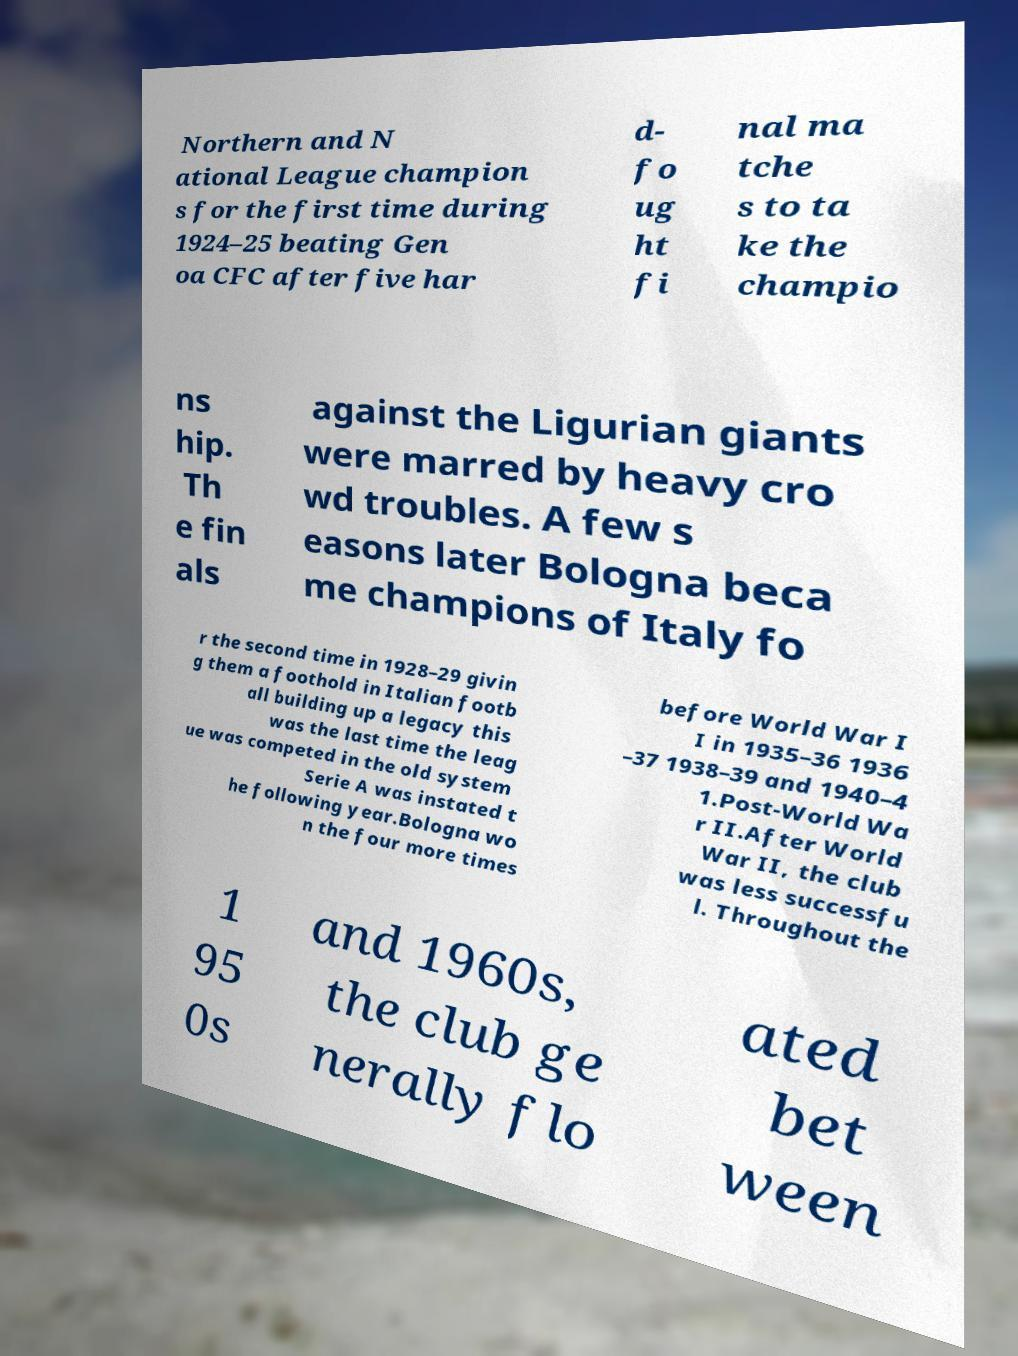What messages or text are displayed in this image? I need them in a readable, typed format. Northern and N ational League champion s for the first time during 1924–25 beating Gen oa CFC after five har d- fo ug ht fi nal ma tche s to ta ke the champio ns hip. Th e fin als against the Ligurian giants were marred by heavy cro wd troubles. A few s easons later Bologna beca me champions of Italy fo r the second time in 1928–29 givin g them a foothold in Italian footb all building up a legacy this was the last time the leag ue was competed in the old system Serie A was instated t he following year.Bologna wo n the four more times before World War I I in 1935–36 1936 –37 1938–39 and 1940–4 1.Post-World Wa r II.After World War II, the club was less successfu l. Throughout the 1 95 0s and 1960s, the club ge nerally flo ated bet ween 